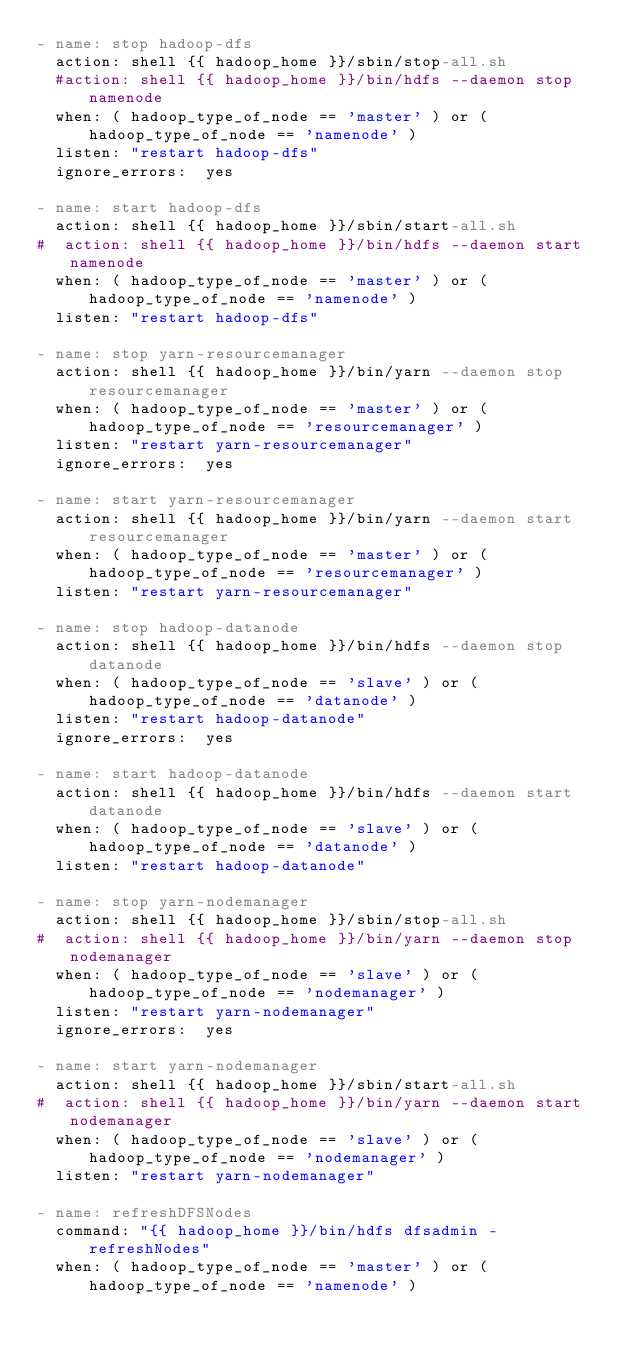Convert code to text. <code><loc_0><loc_0><loc_500><loc_500><_YAML_>- name: stop hadoop-dfs
  action: shell {{ hadoop_home }}/sbin/stop-all.sh
  #action: shell {{ hadoop_home }}/bin/hdfs --daemon stop namenode
  when: ( hadoop_type_of_node == 'master' ) or ( hadoop_type_of_node == 'namenode' )
  listen: "restart hadoop-dfs"
  ignore_errors:  yes

- name: start hadoop-dfs
  action: shell {{ hadoop_home }}/sbin/start-all.sh
#  action: shell {{ hadoop_home }}/bin/hdfs --daemon start namenode
  when: ( hadoop_type_of_node == 'master' ) or ( hadoop_type_of_node == 'namenode' )
  listen: "restart hadoop-dfs"
  
- name: stop yarn-resourcemanager
  action: shell {{ hadoop_home }}/bin/yarn --daemon stop resourcemanager
  when: ( hadoop_type_of_node == 'master' ) or ( hadoop_type_of_node == 'resourcemanager' )
  listen: "restart yarn-resourcemanager"
  ignore_errors:  yes

- name: start yarn-resourcemanager
  action: shell {{ hadoop_home }}/bin/yarn --daemon start resourcemanager
  when: ( hadoop_type_of_node == 'master' ) or ( hadoop_type_of_node == 'resourcemanager' )
  listen: "restart yarn-resourcemanager"

- name: stop hadoop-datanode
  action: shell {{ hadoop_home }}/bin/hdfs --daemon stop datanode
  when: ( hadoop_type_of_node == 'slave' ) or ( hadoop_type_of_node == 'datanode' )
  listen: "restart hadoop-datanode"
  ignore_errors:  yes

- name: start hadoop-datanode
  action: shell {{ hadoop_home }}/bin/hdfs --daemon start datanode
  when: ( hadoop_type_of_node == 'slave' ) or ( hadoop_type_of_node == 'datanode' )
  listen: "restart hadoop-datanode"

- name: stop yarn-nodemanager
  action: shell {{ hadoop_home }}/sbin/stop-all.sh
#  action: shell {{ hadoop_home }}/bin/yarn --daemon stop nodemanager
  when: ( hadoop_type_of_node == 'slave' ) or ( hadoop_type_of_node == 'nodemanager' )
  listen: "restart yarn-nodemanager"
  ignore_errors:  yes

- name: start yarn-nodemanager
  action: shell {{ hadoop_home }}/sbin/start-all.sh
#  action: shell {{ hadoop_home }}/bin/yarn --daemon start nodemanager
  when: ( hadoop_type_of_node == 'slave' ) or ( hadoop_type_of_node == 'nodemanager' )
  listen: "restart yarn-nodemanager"

- name: refreshDFSNodes
  command: "{{ hadoop_home }}/bin/hdfs dfsadmin -refreshNodes"
  when: ( hadoop_type_of_node == 'master' ) or ( hadoop_type_of_node == 'namenode' )</code> 